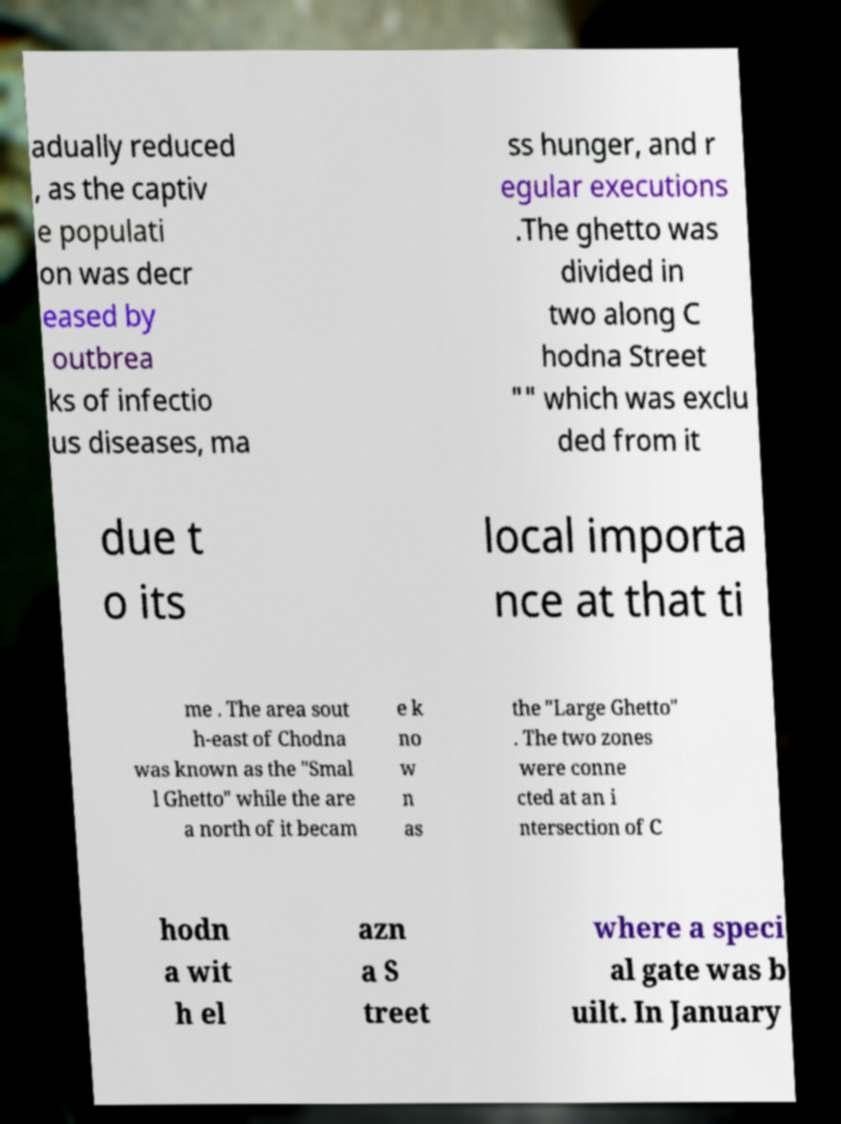I need the written content from this picture converted into text. Can you do that? adually reduced , as the captiv e populati on was decr eased by outbrea ks of infectio us diseases, ma ss hunger, and r egular executions .The ghetto was divided in two along C hodna Street "" which was exclu ded from it due t o its local importa nce at that ti me . The area sout h-east of Chodna was known as the "Smal l Ghetto" while the are a north of it becam e k no w n as the "Large Ghetto" . The two zones were conne cted at an i ntersection of C hodn a wit h el azn a S treet where a speci al gate was b uilt. In January 